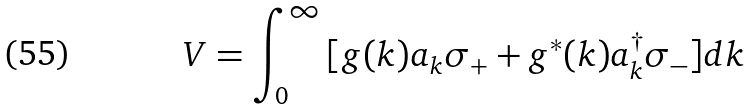Convert formula to latex. <formula><loc_0><loc_0><loc_500><loc_500>V = \int _ { 0 } ^ { \infty } { [ } g ( k ) a _ { k } \sigma _ { + } + g ^ { \ast } ( k ) a _ { k } ^ { \dag } \sigma _ { - } { ] } d k</formula> 